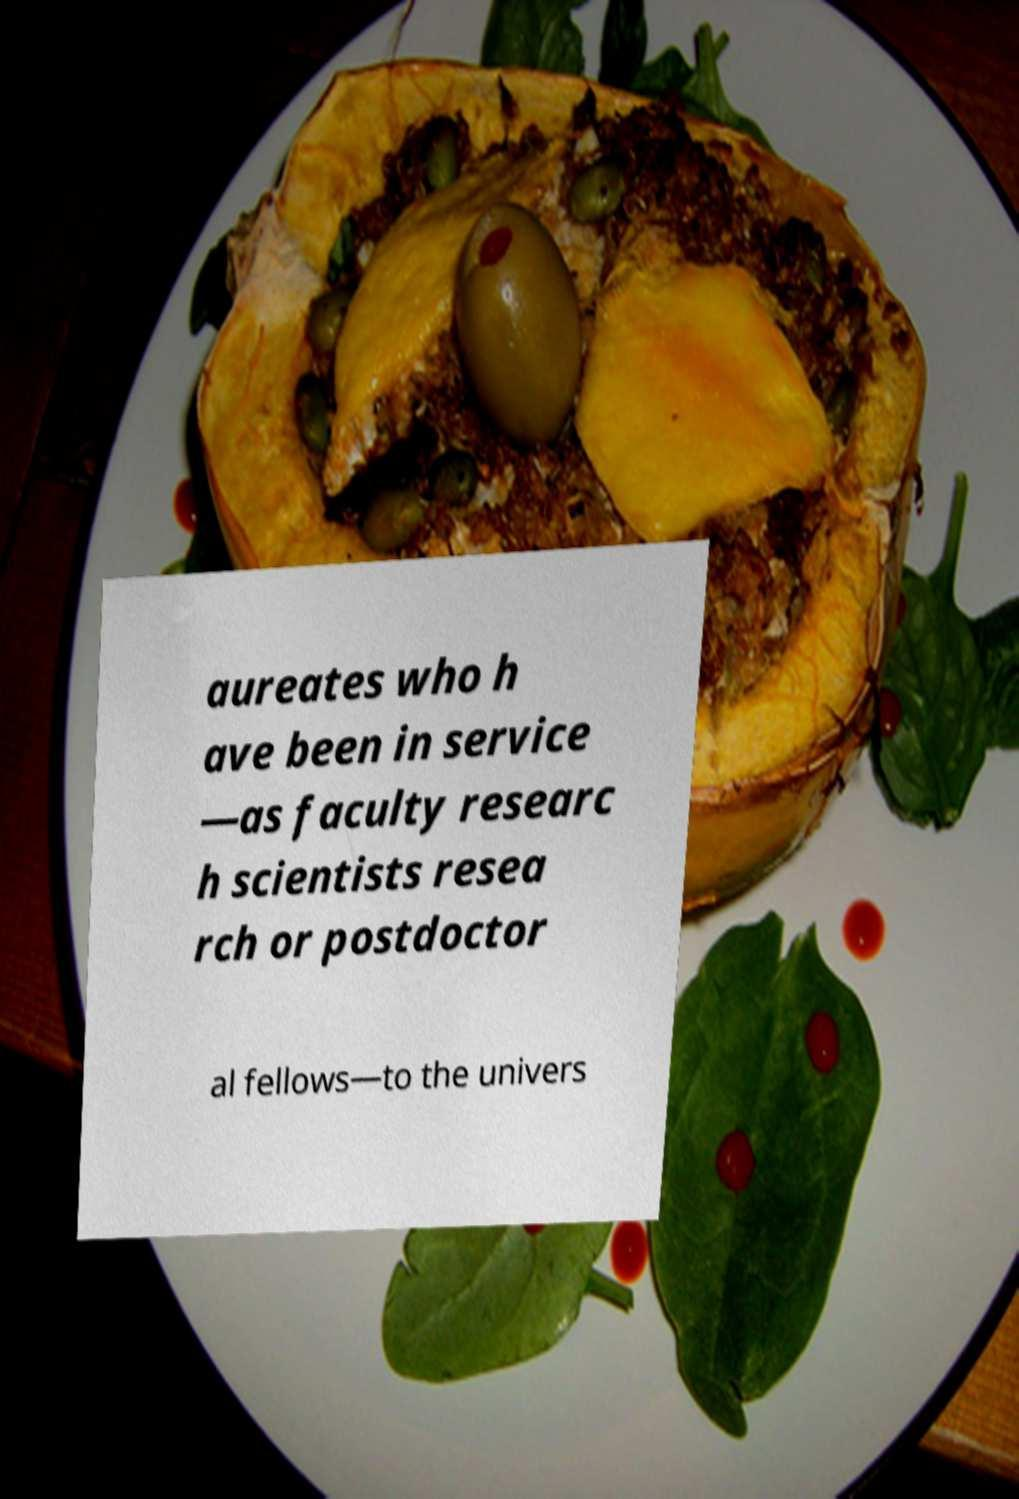I need the written content from this picture converted into text. Can you do that? aureates who h ave been in service —as faculty researc h scientists resea rch or postdoctor al fellows—to the univers 